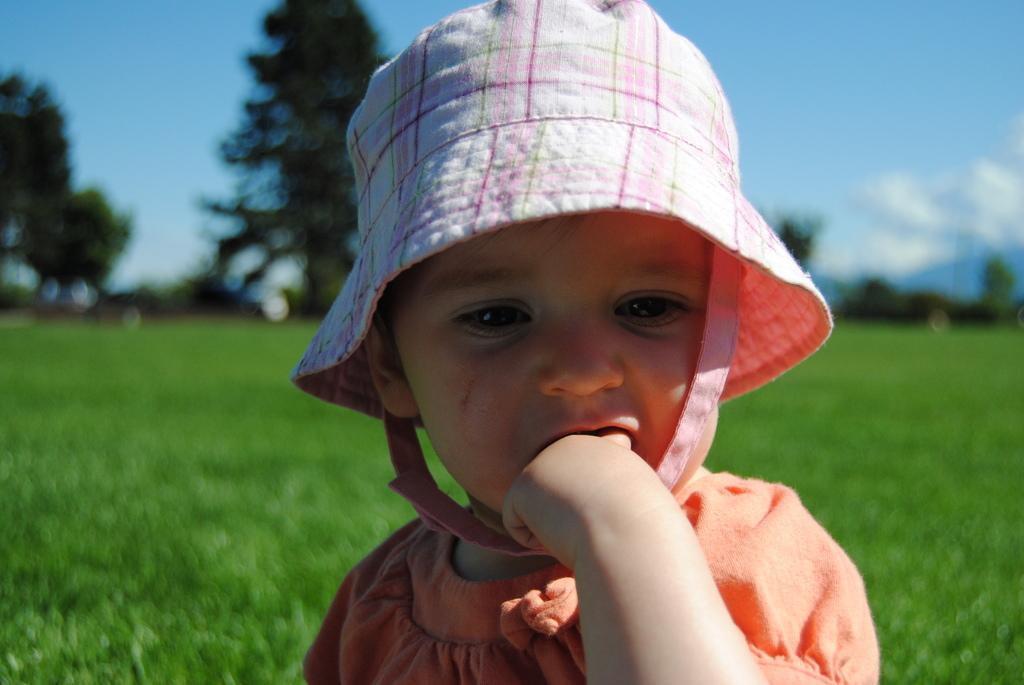What is the main subject of the image? There is a child in the image. What is the child wearing on their head? The child is wearing a hat. What color is the child's dress? The child is wearing an orange dress. What can be seen in the background of the image? There is grass, trees, and the sky visible in the background of the image. What is the condition of the sky in the image? Clouds are present in the sky. What type of meat can be seen hanging from the trees in the image? There is no meat present in the image; it features a child wearing a hat and an orange dress, with grass, trees, and a cloudy sky in the background. 